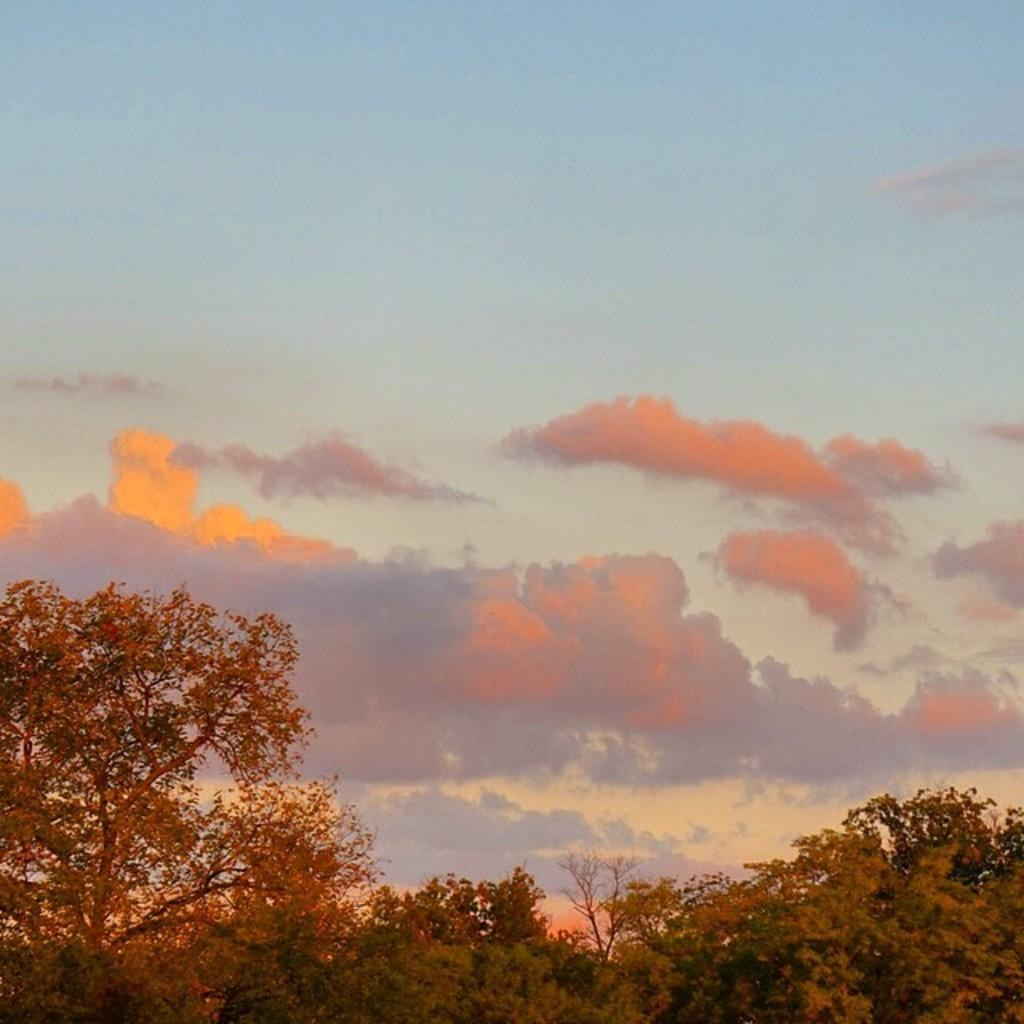What type of vegetation can be seen in the image? There are trees in the image. What part of the natural environment is visible in the image? The sky is visible in the image. Based on the visibility of the sky and trees, can you infer the time of day the image was taken? The image was likely taken during the day, as the sky is visible and there is sufficient light for the trees to be seen. Can you compare the size of the insects in the image to the size of the trees? There are no insects present in the image, so it is not possible to make a comparison. 